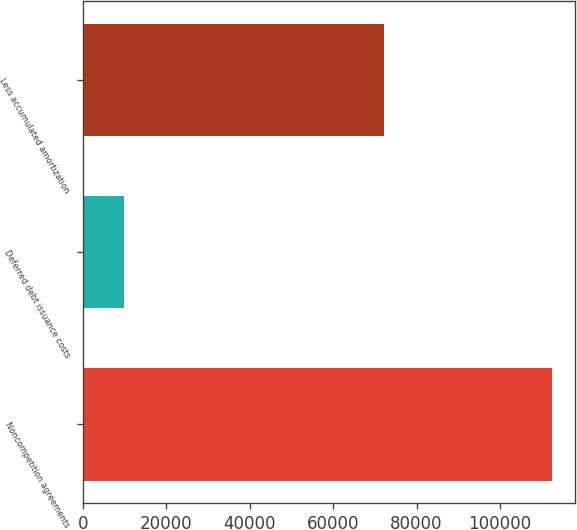Convert chart. <chart><loc_0><loc_0><loc_500><loc_500><bar_chart><fcel>Noncompetition agreements<fcel>Deferred debt issuance costs<fcel>Less accumulated amortization<nl><fcel>112407<fcel>9851<fcel>72287<nl></chart> 